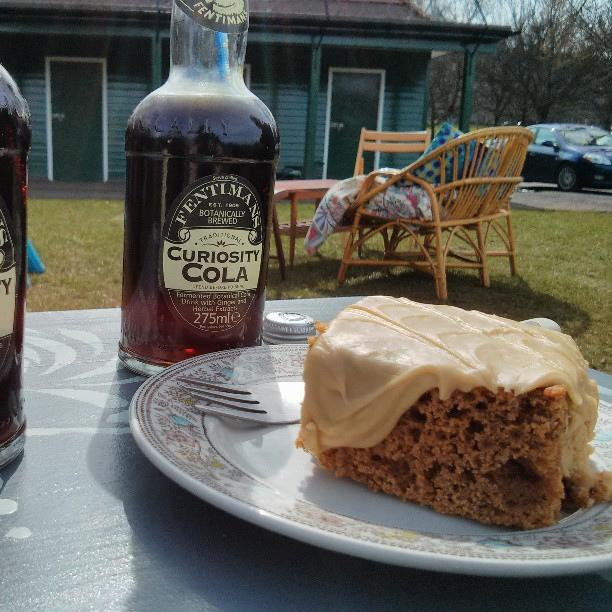What is the fork next to?

Choices:
A) chili
B) cherry pie
C) cake
D) steak cake 